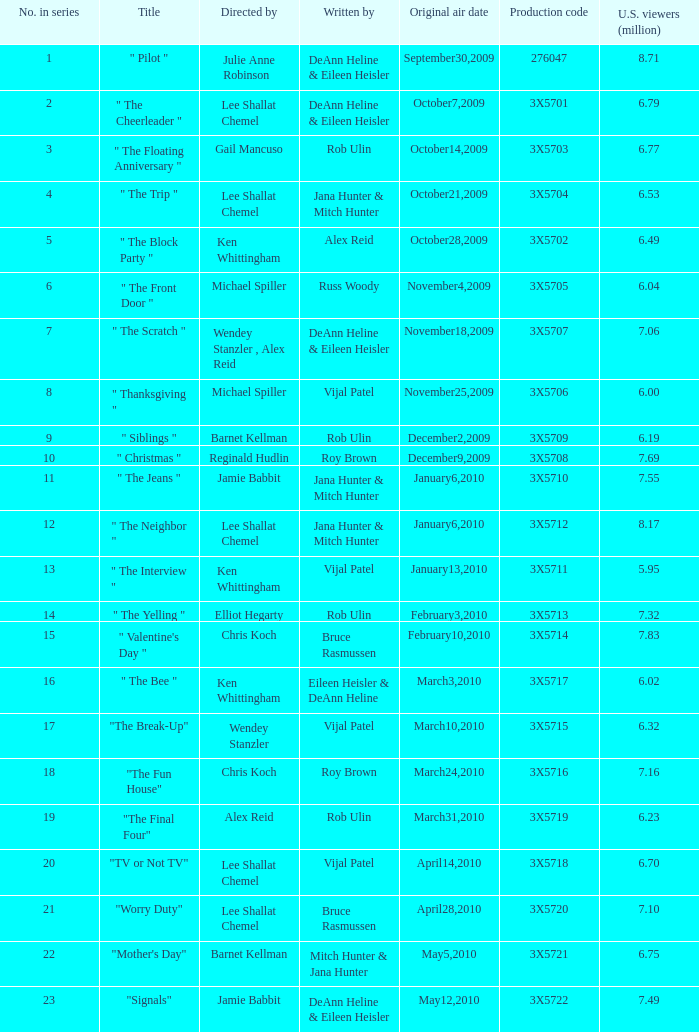Write the full table. {'header': ['No. in series', 'Title', 'Directed by', 'Written by', 'Original air date', 'Production code', 'U.S. viewers (million)'], 'rows': [['1', '" Pilot "', 'Julie Anne Robinson', 'DeAnn Heline & Eileen Heisler', 'September30,2009', '276047', '8.71'], ['2', '" The Cheerleader "', 'Lee Shallat Chemel', 'DeAnn Heline & Eileen Heisler', 'October7,2009', '3X5701', '6.79'], ['3', '" The Floating Anniversary "', 'Gail Mancuso', 'Rob Ulin', 'October14,2009', '3X5703', '6.77'], ['4', '" The Trip "', 'Lee Shallat Chemel', 'Jana Hunter & Mitch Hunter', 'October21,2009', '3X5704', '6.53'], ['5', '" The Block Party "', 'Ken Whittingham', 'Alex Reid', 'October28,2009', '3X5702', '6.49'], ['6', '" The Front Door "', 'Michael Spiller', 'Russ Woody', 'November4,2009', '3X5705', '6.04'], ['7', '" The Scratch "', 'Wendey Stanzler , Alex Reid', 'DeAnn Heline & Eileen Heisler', 'November18,2009', '3X5707', '7.06'], ['8', '" Thanksgiving "', 'Michael Spiller', 'Vijal Patel', 'November25,2009', '3X5706', '6.00'], ['9', '" Siblings "', 'Barnet Kellman', 'Rob Ulin', 'December2,2009', '3X5709', '6.19'], ['10', '" Christmas "', 'Reginald Hudlin', 'Roy Brown', 'December9,2009', '3X5708', '7.69'], ['11', '" The Jeans "', 'Jamie Babbit', 'Jana Hunter & Mitch Hunter', 'January6,2010', '3X5710', '7.55'], ['12', '" The Neighbor "', 'Lee Shallat Chemel', 'Jana Hunter & Mitch Hunter', 'January6,2010', '3X5712', '8.17'], ['13', '" The Interview "', 'Ken Whittingham', 'Vijal Patel', 'January13,2010', '3X5711', '5.95'], ['14', '" The Yelling "', 'Elliot Hegarty', 'Rob Ulin', 'February3,2010', '3X5713', '7.32'], ['15', '" Valentine\'s Day "', 'Chris Koch', 'Bruce Rasmussen', 'February10,2010', '3X5714', '7.83'], ['16', '" The Bee "', 'Ken Whittingham', 'Eileen Heisler & DeAnn Heline', 'March3,2010', '3X5717', '6.02'], ['17', '"The Break-Up"', 'Wendey Stanzler', 'Vijal Patel', 'March10,2010', '3X5715', '6.32'], ['18', '"The Fun House"', 'Chris Koch', 'Roy Brown', 'March24,2010', '3X5716', '7.16'], ['19', '"The Final Four"', 'Alex Reid', 'Rob Ulin', 'March31,2010', '3X5719', '6.23'], ['20', '"TV or Not TV"', 'Lee Shallat Chemel', 'Vijal Patel', 'April14,2010', '3X5718', '6.70'], ['21', '"Worry Duty"', 'Lee Shallat Chemel', 'Bruce Rasmussen', 'April28,2010', '3X5720', '7.10'], ['22', '"Mother\'s Day"', 'Barnet Kellman', 'Mitch Hunter & Jana Hunter', 'May5,2010', '3X5721', '6.75'], ['23', '"Signals"', 'Jamie Babbit', 'DeAnn Heline & Eileen Heisler', 'May12,2010', '3X5722', '7.49']]} How many directors attracted 6.79 million u.s. viewers for their episodes? 1.0. 